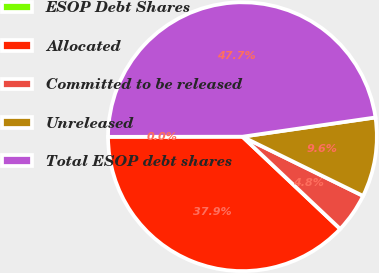Convert chart. <chart><loc_0><loc_0><loc_500><loc_500><pie_chart><fcel>ESOP Debt Shares<fcel>Allocated<fcel>Committed to be released<fcel>Unreleased<fcel>Total ESOP debt shares<nl><fcel>0.0%<fcel>37.94%<fcel>4.78%<fcel>9.55%<fcel>47.73%<nl></chart> 